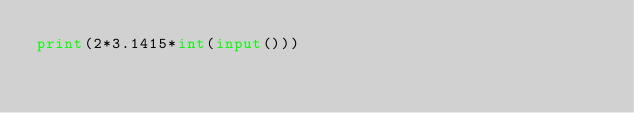Convert code to text. <code><loc_0><loc_0><loc_500><loc_500><_Python_>print(2*3.1415*int(input()))
</code> 